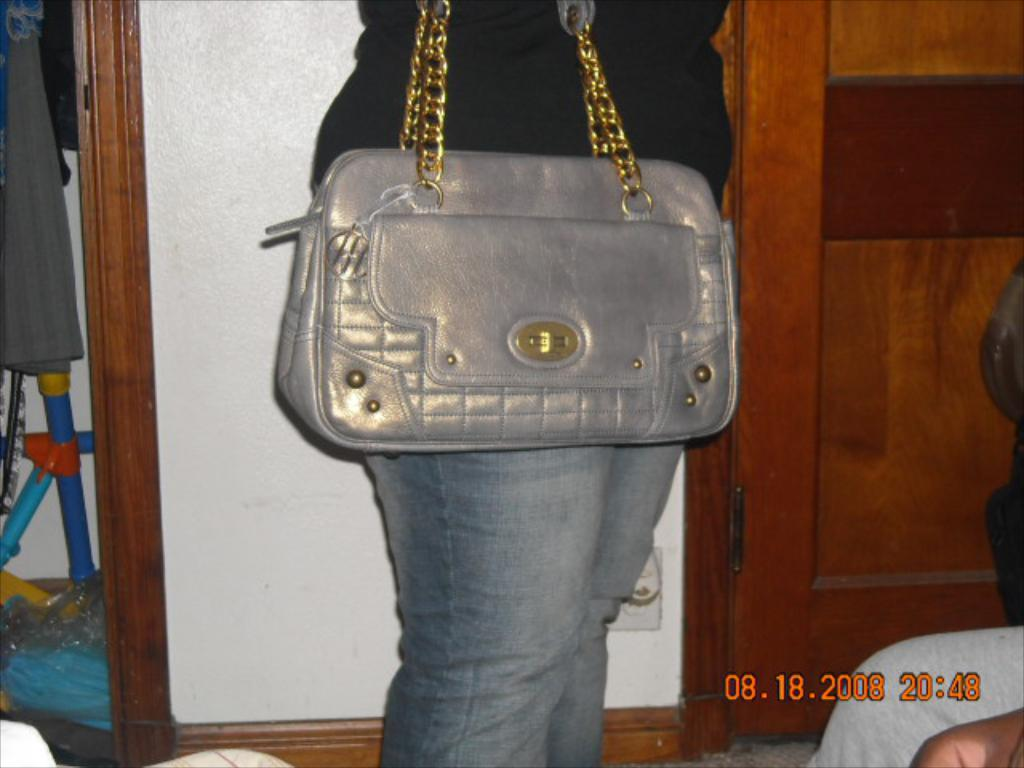What is the main subject of the image? There is a person standing in the image. What is the person wearing in the image? The person is wearing a handbag. What can be seen at the top of the image? There is a wall on the top of the image. What is located on the right side of the image? There is a door on the right side of the image. What type of produce is being served in a bowl on the left side of the image? There is no bowl of produce present in the image. What type of soup is the person eating in the image? There is no soup present in the image. Can you see a robin perched on the wall in the image? There is no robin present in the image. 